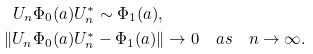<formula> <loc_0><loc_0><loc_500><loc_500>U _ { n } \Phi _ { 0 } ( a ) U _ { n } ^ { * } & \sim \Phi _ { 1 } ( a ) , \\ \| U _ { n } \Phi _ { 0 } ( a ) U _ { n } ^ { * } & - \Phi _ { 1 } ( a ) \| \rightarrow 0 \quad a s \quad n \to \infty .</formula> 